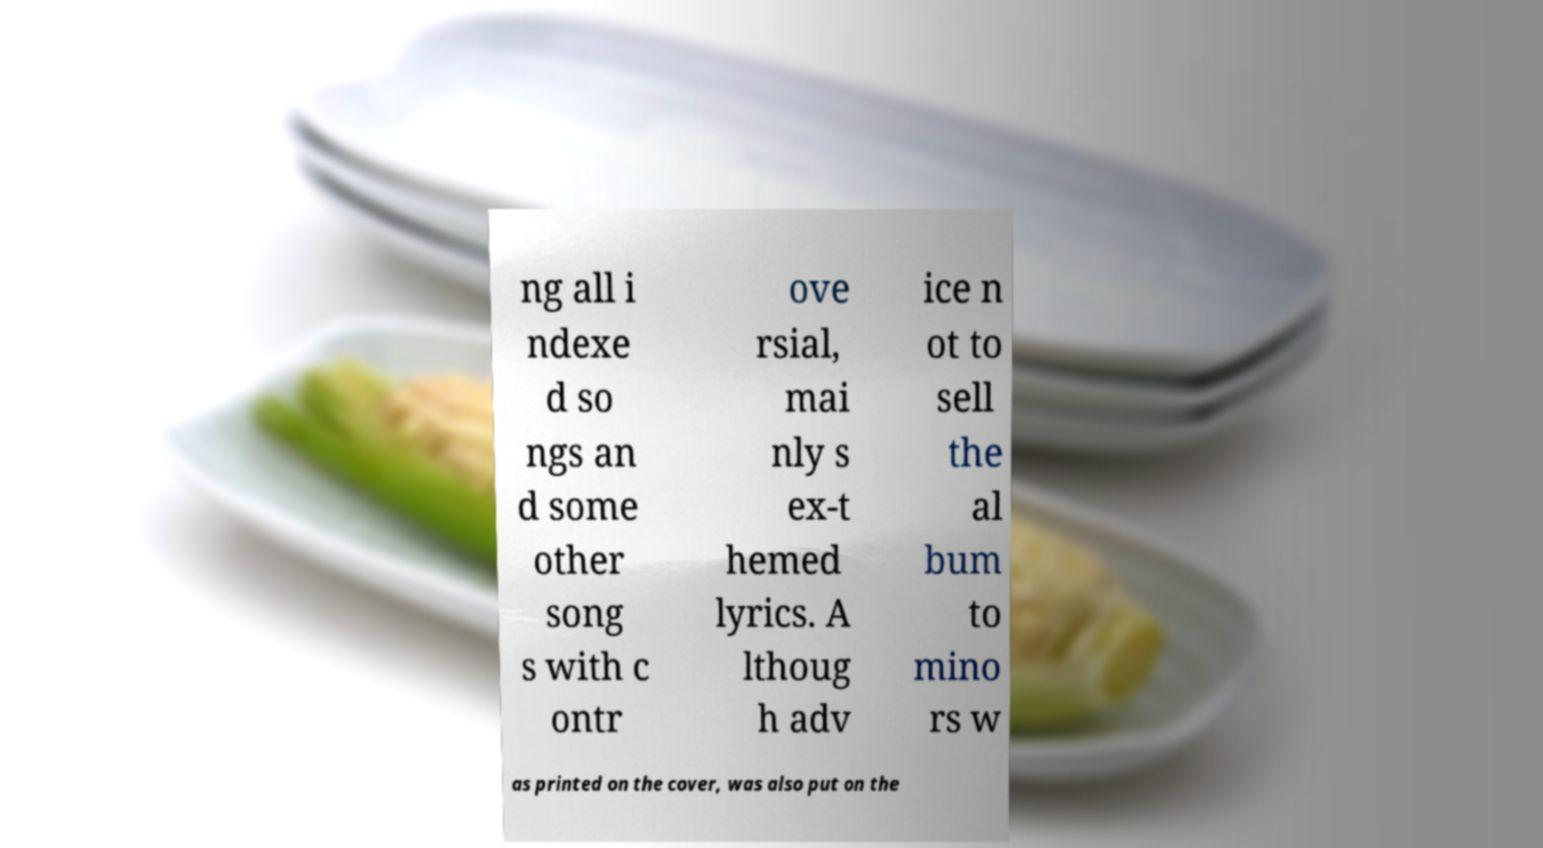Could you extract and type out the text from this image? ng all i ndexe d so ngs an d some other song s with c ontr ove rsial, mai nly s ex-t hemed lyrics. A lthoug h adv ice n ot to sell the al bum to mino rs w as printed on the cover, was also put on the 